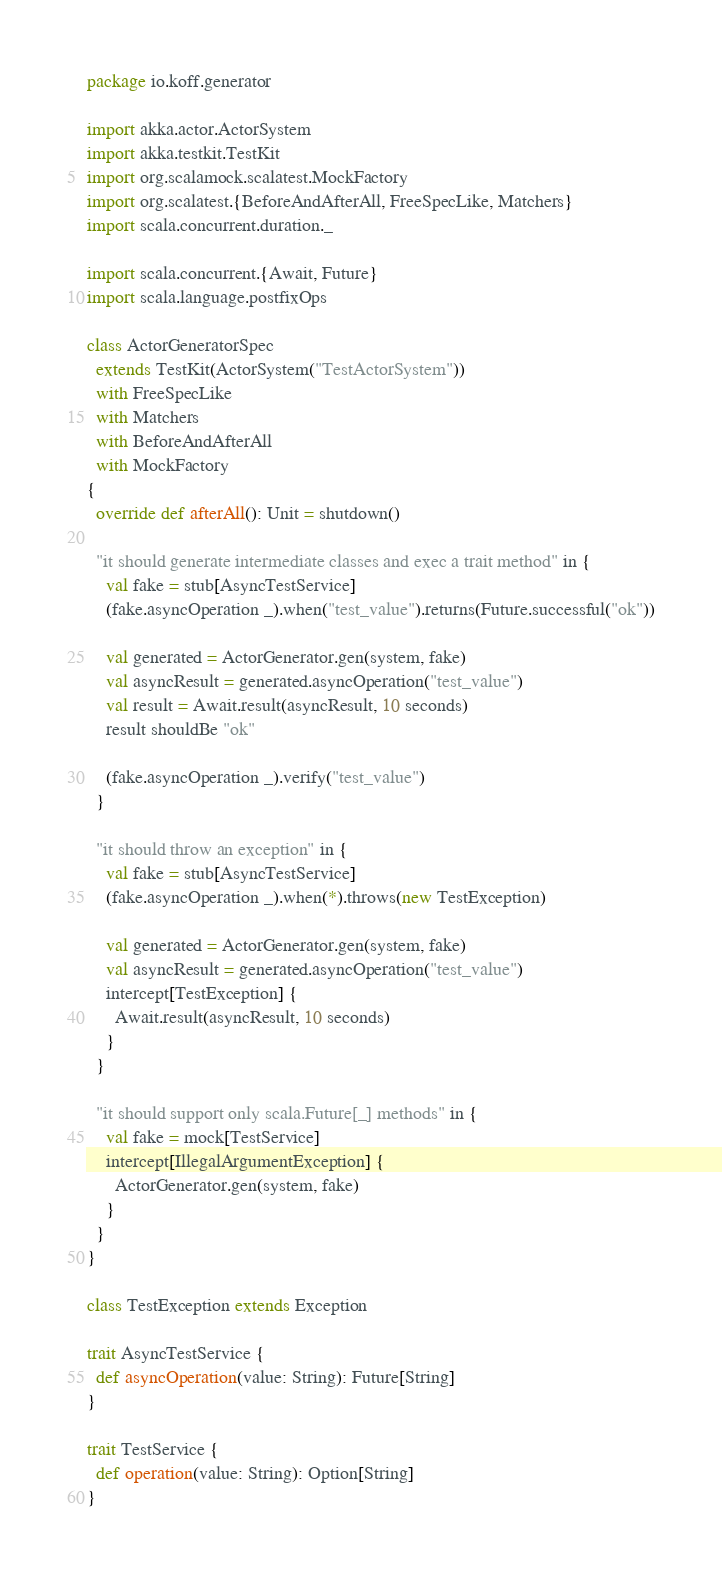Convert code to text. <code><loc_0><loc_0><loc_500><loc_500><_Scala_>package io.koff.generator

import akka.actor.ActorSystem
import akka.testkit.TestKit
import org.scalamock.scalatest.MockFactory
import org.scalatest.{BeforeAndAfterAll, FreeSpecLike, Matchers}
import scala.concurrent.duration._

import scala.concurrent.{Await, Future}
import scala.language.postfixOps

class ActorGeneratorSpec
  extends TestKit(ActorSystem("TestActorSystem"))
  with FreeSpecLike
  with Matchers
  with BeforeAndAfterAll
  with MockFactory
{
  override def afterAll(): Unit = shutdown()

  "it should generate intermediate classes and exec a trait method" in {
    val fake = stub[AsyncTestService]
    (fake.asyncOperation _).when("test_value").returns(Future.successful("ok"))

    val generated = ActorGenerator.gen(system, fake)
    val asyncResult = generated.asyncOperation("test_value")
    val result = Await.result(asyncResult, 10 seconds)
    result shouldBe "ok"

    (fake.asyncOperation _).verify("test_value")
  }

  "it should throw an exception" in {
    val fake = stub[AsyncTestService]
    (fake.asyncOperation _).when(*).throws(new TestException)

    val generated = ActorGenerator.gen(system, fake)
    val asyncResult = generated.asyncOperation("test_value")
    intercept[TestException] {
      Await.result(asyncResult, 10 seconds)
    }
  }

  "it should support only scala.Future[_] methods" in {
    val fake = mock[TestService]
    intercept[IllegalArgumentException] {
      ActorGenerator.gen(system, fake)
    }
  }
}

class TestException extends Exception

trait AsyncTestService {
  def asyncOperation(value: String): Future[String]
}

trait TestService {
  def operation(value: String): Option[String]
}</code> 